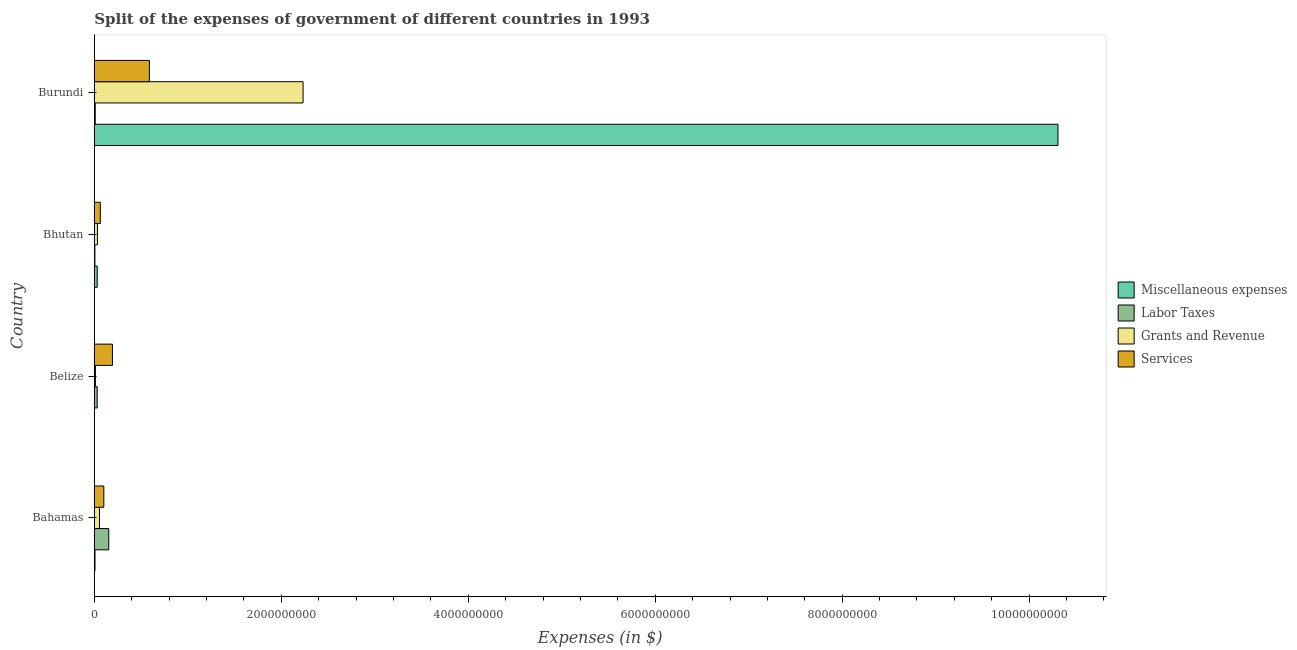Are the number of bars per tick equal to the number of legend labels?
Give a very brief answer. Yes. How many bars are there on the 4th tick from the top?
Provide a succinct answer. 4. How many bars are there on the 4th tick from the bottom?
Keep it short and to the point. 4. What is the label of the 4th group of bars from the top?
Provide a short and direct response. Bahamas. In how many cases, is the number of bars for a given country not equal to the number of legend labels?
Your answer should be compact. 0. What is the amount spent on grants and revenue in Belize?
Ensure brevity in your answer.  1.21e+07. Across all countries, what is the maximum amount spent on miscellaneous expenses?
Offer a very short reply. 1.03e+1. Across all countries, what is the minimum amount spent on services?
Give a very brief answer. 6.46e+07. In which country was the amount spent on services maximum?
Provide a short and direct response. Burundi. In which country was the amount spent on grants and revenue minimum?
Your response must be concise. Belize. What is the total amount spent on grants and revenue in the graph?
Your response must be concise. 2.33e+09. What is the difference between the amount spent on grants and revenue in Bhutan and that in Burundi?
Keep it short and to the point. -2.20e+09. What is the difference between the amount spent on services in Burundi and the amount spent on grants and revenue in Bahamas?
Make the answer very short. 5.34e+08. What is the average amount spent on services per country?
Keep it short and to the point. 2.38e+08. What is the difference between the amount spent on labor taxes and amount spent on grants and revenue in Bhutan?
Keep it short and to the point. -2.73e+07. What is the ratio of the amount spent on miscellaneous expenses in Bahamas to that in Belize?
Ensure brevity in your answer.  4.55. What is the difference between the highest and the second highest amount spent on grants and revenue?
Provide a short and direct response. 2.18e+09. What is the difference between the highest and the lowest amount spent on miscellaneous expenses?
Your answer should be compact. 1.03e+1. In how many countries, is the amount spent on labor taxes greater than the average amount spent on labor taxes taken over all countries?
Ensure brevity in your answer.  1. Is the sum of the amount spent on services in Bahamas and Bhutan greater than the maximum amount spent on grants and revenue across all countries?
Give a very brief answer. No. What does the 2nd bar from the top in Bahamas represents?
Provide a short and direct response. Grants and Revenue. What does the 1st bar from the bottom in Bahamas represents?
Give a very brief answer. Miscellaneous expenses. How many bars are there?
Keep it short and to the point. 16. Are all the bars in the graph horizontal?
Make the answer very short. Yes. What is the difference between two consecutive major ticks on the X-axis?
Offer a very short reply. 2.00e+09. Are the values on the major ticks of X-axis written in scientific E-notation?
Offer a very short reply. No. Does the graph contain any zero values?
Keep it short and to the point. No. What is the title of the graph?
Your answer should be very brief. Split of the expenses of government of different countries in 1993. Does "Budget management" appear as one of the legend labels in the graph?
Provide a short and direct response. No. What is the label or title of the X-axis?
Make the answer very short. Expenses (in $). What is the Expenses (in $) of Miscellaneous expenses in Bahamas?
Provide a short and direct response. 7.60e+06. What is the Expenses (in $) of Labor Taxes in Bahamas?
Ensure brevity in your answer.  1.55e+08. What is the Expenses (in $) in Grants and Revenue in Bahamas?
Give a very brief answer. 5.55e+07. What is the Expenses (in $) of Services in Bahamas?
Your answer should be compact. 1.02e+08. What is the Expenses (in $) in Miscellaneous expenses in Belize?
Ensure brevity in your answer.  1.67e+06. What is the Expenses (in $) of Labor Taxes in Belize?
Provide a short and direct response. 3.09e+07. What is the Expenses (in $) of Grants and Revenue in Belize?
Make the answer very short. 1.21e+07. What is the Expenses (in $) of Services in Belize?
Provide a short and direct response. 1.94e+08. What is the Expenses (in $) in Miscellaneous expenses in Bhutan?
Your answer should be very brief. 3.13e+07. What is the Expenses (in $) in Labor Taxes in Bhutan?
Your answer should be compact. 6.38e+06. What is the Expenses (in $) in Grants and Revenue in Bhutan?
Your answer should be very brief. 3.37e+07. What is the Expenses (in $) in Services in Bhutan?
Your answer should be compact. 6.46e+07. What is the Expenses (in $) in Miscellaneous expenses in Burundi?
Provide a short and direct response. 1.03e+1. What is the Expenses (in $) of Labor Taxes in Burundi?
Make the answer very short. 1.02e+07. What is the Expenses (in $) in Grants and Revenue in Burundi?
Give a very brief answer. 2.23e+09. What is the Expenses (in $) in Services in Burundi?
Offer a very short reply. 5.90e+08. Across all countries, what is the maximum Expenses (in $) in Miscellaneous expenses?
Make the answer very short. 1.03e+1. Across all countries, what is the maximum Expenses (in $) in Labor Taxes?
Your answer should be very brief. 1.55e+08. Across all countries, what is the maximum Expenses (in $) of Grants and Revenue?
Make the answer very short. 2.23e+09. Across all countries, what is the maximum Expenses (in $) of Services?
Offer a terse response. 5.90e+08. Across all countries, what is the minimum Expenses (in $) of Miscellaneous expenses?
Provide a succinct answer. 1.67e+06. Across all countries, what is the minimum Expenses (in $) of Labor Taxes?
Provide a succinct answer. 6.38e+06. Across all countries, what is the minimum Expenses (in $) in Grants and Revenue?
Keep it short and to the point. 1.21e+07. Across all countries, what is the minimum Expenses (in $) of Services?
Give a very brief answer. 6.46e+07. What is the total Expenses (in $) in Miscellaneous expenses in the graph?
Offer a very short reply. 1.03e+1. What is the total Expenses (in $) of Labor Taxes in the graph?
Your answer should be very brief. 2.02e+08. What is the total Expenses (in $) of Grants and Revenue in the graph?
Ensure brevity in your answer.  2.33e+09. What is the total Expenses (in $) of Services in the graph?
Make the answer very short. 9.50e+08. What is the difference between the Expenses (in $) in Miscellaneous expenses in Bahamas and that in Belize?
Your response must be concise. 5.93e+06. What is the difference between the Expenses (in $) in Labor Taxes in Bahamas and that in Belize?
Keep it short and to the point. 1.24e+08. What is the difference between the Expenses (in $) of Grants and Revenue in Bahamas and that in Belize?
Make the answer very short. 4.34e+07. What is the difference between the Expenses (in $) in Services in Bahamas and that in Belize?
Offer a very short reply. -9.22e+07. What is the difference between the Expenses (in $) in Miscellaneous expenses in Bahamas and that in Bhutan?
Provide a succinct answer. -2.37e+07. What is the difference between the Expenses (in $) in Labor Taxes in Bahamas and that in Bhutan?
Offer a very short reply. 1.48e+08. What is the difference between the Expenses (in $) in Grants and Revenue in Bahamas and that in Bhutan?
Provide a succinct answer. 2.18e+07. What is the difference between the Expenses (in $) in Services in Bahamas and that in Bhutan?
Ensure brevity in your answer.  3.73e+07. What is the difference between the Expenses (in $) in Miscellaneous expenses in Bahamas and that in Burundi?
Give a very brief answer. -1.03e+1. What is the difference between the Expenses (in $) in Labor Taxes in Bahamas and that in Burundi?
Provide a succinct answer. 1.45e+08. What is the difference between the Expenses (in $) in Grants and Revenue in Bahamas and that in Burundi?
Make the answer very short. -2.18e+09. What is the difference between the Expenses (in $) of Services in Bahamas and that in Burundi?
Make the answer very short. -4.88e+08. What is the difference between the Expenses (in $) in Miscellaneous expenses in Belize and that in Bhutan?
Offer a very short reply. -2.96e+07. What is the difference between the Expenses (in $) in Labor Taxes in Belize and that in Bhutan?
Offer a terse response. 2.45e+07. What is the difference between the Expenses (in $) in Grants and Revenue in Belize and that in Bhutan?
Offer a very short reply. -2.16e+07. What is the difference between the Expenses (in $) of Services in Belize and that in Bhutan?
Give a very brief answer. 1.30e+08. What is the difference between the Expenses (in $) of Miscellaneous expenses in Belize and that in Burundi?
Offer a terse response. -1.03e+1. What is the difference between the Expenses (in $) of Labor Taxes in Belize and that in Burundi?
Keep it short and to the point. 2.07e+07. What is the difference between the Expenses (in $) of Grants and Revenue in Belize and that in Burundi?
Ensure brevity in your answer.  -2.22e+09. What is the difference between the Expenses (in $) of Services in Belize and that in Burundi?
Provide a succinct answer. -3.96e+08. What is the difference between the Expenses (in $) in Miscellaneous expenses in Bhutan and that in Burundi?
Your answer should be compact. -1.03e+1. What is the difference between the Expenses (in $) of Labor Taxes in Bhutan and that in Burundi?
Provide a short and direct response. -3.82e+06. What is the difference between the Expenses (in $) in Grants and Revenue in Bhutan and that in Burundi?
Keep it short and to the point. -2.20e+09. What is the difference between the Expenses (in $) of Services in Bhutan and that in Burundi?
Provide a succinct answer. -5.25e+08. What is the difference between the Expenses (in $) of Miscellaneous expenses in Bahamas and the Expenses (in $) of Labor Taxes in Belize?
Your answer should be compact. -2.33e+07. What is the difference between the Expenses (in $) in Miscellaneous expenses in Bahamas and the Expenses (in $) in Grants and Revenue in Belize?
Make the answer very short. -4.50e+06. What is the difference between the Expenses (in $) in Miscellaneous expenses in Bahamas and the Expenses (in $) in Services in Belize?
Your response must be concise. -1.86e+08. What is the difference between the Expenses (in $) in Labor Taxes in Bahamas and the Expenses (in $) in Grants and Revenue in Belize?
Ensure brevity in your answer.  1.43e+08. What is the difference between the Expenses (in $) in Labor Taxes in Bahamas and the Expenses (in $) in Services in Belize?
Ensure brevity in your answer.  -3.93e+07. What is the difference between the Expenses (in $) of Grants and Revenue in Bahamas and the Expenses (in $) of Services in Belize?
Your response must be concise. -1.39e+08. What is the difference between the Expenses (in $) in Miscellaneous expenses in Bahamas and the Expenses (in $) in Labor Taxes in Bhutan?
Make the answer very short. 1.22e+06. What is the difference between the Expenses (in $) of Miscellaneous expenses in Bahamas and the Expenses (in $) of Grants and Revenue in Bhutan?
Your response must be concise. -2.61e+07. What is the difference between the Expenses (in $) in Miscellaneous expenses in Bahamas and the Expenses (in $) in Services in Bhutan?
Give a very brief answer. -5.70e+07. What is the difference between the Expenses (in $) in Labor Taxes in Bahamas and the Expenses (in $) in Grants and Revenue in Bhutan?
Offer a terse response. 1.21e+08. What is the difference between the Expenses (in $) of Labor Taxes in Bahamas and the Expenses (in $) of Services in Bhutan?
Ensure brevity in your answer.  9.02e+07. What is the difference between the Expenses (in $) of Grants and Revenue in Bahamas and the Expenses (in $) of Services in Bhutan?
Your response must be concise. -9.07e+06. What is the difference between the Expenses (in $) of Miscellaneous expenses in Bahamas and the Expenses (in $) of Labor Taxes in Burundi?
Give a very brief answer. -2.60e+06. What is the difference between the Expenses (in $) of Miscellaneous expenses in Bahamas and the Expenses (in $) of Grants and Revenue in Burundi?
Keep it short and to the point. -2.23e+09. What is the difference between the Expenses (in $) in Miscellaneous expenses in Bahamas and the Expenses (in $) in Services in Burundi?
Make the answer very short. -5.82e+08. What is the difference between the Expenses (in $) in Labor Taxes in Bahamas and the Expenses (in $) in Grants and Revenue in Burundi?
Give a very brief answer. -2.08e+09. What is the difference between the Expenses (in $) in Labor Taxes in Bahamas and the Expenses (in $) in Services in Burundi?
Provide a succinct answer. -4.35e+08. What is the difference between the Expenses (in $) in Grants and Revenue in Bahamas and the Expenses (in $) in Services in Burundi?
Ensure brevity in your answer.  -5.34e+08. What is the difference between the Expenses (in $) of Miscellaneous expenses in Belize and the Expenses (in $) of Labor Taxes in Bhutan?
Give a very brief answer. -4.71e+06. What is the difference between the Expenses (in $) in Miscellaneous expenses in Belize and the Expenses (in $) in Grants and Revenue in Bhutan?
Make the answer very short. -3.20e+07. What is the difference between the Expenses (in $) of Miscellaneous expenses in Belize and the Expenses (in $) of Services in Bhutan?
Offer a very short reply. -6.29e+07. What is the difference between the Expenses (in $) of Labor Taxes in Belize and the Expenses (in $) of Grants and Revenue in Bhutan?
Make the answer very short. -2.81e+06. What is the difference between the Expenses (in $) of Labor Taxes in Belize and the Expenses (in $) of Services in Bhutan?
Your answer should be compact. -3.37e+07. What is the difference between the Expenses (in $) in Grants and Revenue in Belize and the Expenses (in $) in Services in Bhutan?
Ensure brevity in your answer.  -5.25e+07. What is the difference between the Expenses (in $) in Miscellaneous expenses in Belize and the Expenses (in $) in Labor Taxes in Burundi?
Offer a very short reply. -8.53e+06. What is the difference between the Expenses (in $) in Miscellaneous expenses in Belize and the Expenses (in $) in Grants and Revenue in Burundi?
Offer a terse response. -2.23e+09. What is the difference between the Expenses (in $) in Miscellaneous expenses in Belize and the Expenses (in $) in Services in Burundi?
Ensure brevity in your answer.  -5.88e+08. What is the difference between the Expenses (in $) of Labor Taxes in Belize and the Expenses (in $) of Grants and Revenue in Burundi?
Your answer should be very brief. -2.20e+09. What is the difference between the Expenses (in $) of Labor Taxes in Belize and the Expenses (in $) of Services in Burundi?
Your answer should be compact. -5.59e+08. What is the difference between the Expenses (in $) in Grants and Revenue in Belize and the Expenses (in $) in Services in Burundi?
Offer a terse response. -5.78e+08. What is the difference between the Expenses (in $) in Miscellaneous expenses in Bhutan and the Expenses (in $) in Labor Taxes in Burundi?
Your answer should be compact. 2.11e+07. What is the difference between the Expenses (in $) in Miscellaneous expenses in Bhutan and the Expenses (in $) in Grants and Revenue in Burundi?
Your response must be concise. -2.20e+09. What is the difference between the Expenses (in $) in Miscellaneous expenses in Bhutan and the Expenses (in $) in Services in Burundi?
Give a very brief answer. -5.58e+08. What is the difference between the Expenses (in $) of Labor Taxes in Bhutan and the Expenses (in $) of Grants and Revenue in Burundi?
Provide a short and direct response. -2.23e+09. What is the difference between the Expenses (in $) of Labor Taxes in Bhutan and the Expenses (in $) of Services in Burundi?
Your answer should be very brief. -5.83e+08. What is the difference between the Expenses (in $) of Grants and Revenue in Bhutan and the Expenses (in $) of Services in Burundi?
Provide a succinct answer. -5.56e+08. What is the average Expenses (in $) in Miscellaneous expenses per country?
Your answer should be compact. 2.59e+09. What is the average Expenses (in $) in Labor Taxes per country?
Keep it short and to the point. 5.06e+07. What is the average Expenses (in $) of Grants and Revenue per country?
Provide a short and direct response. 5.84e+08. What is the average Expenses (in $) of Services per country?
Your answer should be very brief. 2.38e+08. What is the difference between the Expenses (in $) in Miscellaneous expenses and Expenses (in $) in Labor Taxes in Bahamas?
Give a very brief answer. -1.47e+08. What is the difference between the Expenses (in $) in Miscellaneous expenses and Expenses (in $) in Grants and Revenue in Bahamas?
Ensure brevity in your answer.  -4.79e+07. What is the difference between the Expenses (in $) in Miscellaneous expenses and Expenses (in $) in Services in Bahamas?
Your answer should be very brief. -9.43e+07. What is the difference between the Expenses (in $) in Labor Taxes and Expenses (in $) in Grants and Revenue in Bahamas?
Give a very brief answer. 9.93e+07. What is the difference between the Expenses (in $) in Labor Taxes and Expenses (in $) in Services in Bahamas?
Your response must be concise. 5.29e+07. What is the difference between the Expenses (in $) in Grants and Revenue and Expenses (in $) in Services in Bahamas?
Keep it short and to the point. -4.64e+07. What is the difference between the Expenses (in $) in Miscellaneous expenses and Expenses (in $) in Labor Taxes in Belize?
Provide a short and direct response. -2.92e+07. What is the difference between the Expenses (in $) of Miscellaneous expenses and Expenses (in $) of Grants and Revenue in Belize?
Your answer should be compact. -1.04e+07. What is the difference between the Expenses (in $) of Miscellaneous expenses and Expenses (in $) of Services in Belize?
Offer a very short reply. -1.92e+08. What is the difference between the Expenses (in $) in Labor Taxes and Expenses (in $) in Grants and Revenue in Belize?
Your answer should be compact. 1.88e+07. What is the difference between the Expenses (in $) of Labor Taxes and Expenses (in $) of Services in Belize?
Give a very brief answer. -1.63e+08. What is the difference between the Expenses (in $) of Grants and Revenue and Expenses (in $) of Services in Belize?
Your response must be concise. -1.82e+08. What is the difference between the Expenses (in $) of Miscellaneous expenses and Expenses (in $) of Labor Taxes in Bhutan?
Make the answer very short. 2.49e+07. What is the difference between the Expenses (in $) of Miscellaneous expenses and Expenses (in $) of Grants and Revenue in Bhutan?
Offer a very short reply. -2.41e+06. What is the difference between the Expenses (in $) of Miscellaneous expenses and Expenses (in $) of Services in Bhutan?
Your answer should be very brief. -3.33e+07. What is the difference between the Expenses (in $) in Labor Taxes and Expenses (in $) in Grants and Revenue in Bhutan?
Offer a very short reply. -2.73e+07. What is the difference between the Expenses (in $) in Labor Taxes and Expenses (in $) in Services in Bhutan?
Make the answer very short. -5.82e+07. What is the difference between the Expenses (in $) of Grants and Revenue and Expenses (in $) of Services in Bhutan?
Ensure brevity in your answer.  -3.09e+07. What is the difference between the Expenses (in $) of Miscellaneous expenses and Expenses (in $) of Labor Taxes in Burundi?
Provide a short and direct response. 1.03e+1. What is the difference between the Expenses (in $) in Miscellaneous expenses and Expenses (in $) in Grants and Revenue in Burundi?
Offer a very short reply. 8.07e+09. What is the difference between the Expenses (in $) in Miscellaneous expenses and Expenses (in $) in Services in Burundi?
Provide a short and direct response. 9.72e+09. What is the difference between the Expenses (in $) of Labor Taxes and Expenses (in $) of Grants and Revenue in Burundi?
Ensure brevity in your answer.  -2.22e+09. What is the difference between the Expenses (in $) of Labor Taxes and Expenses (in $) of Services in Burundi?
Offer a very short reply. -5.80e+08. What is the difference between the Expenses (in $) of Grants and Revenue and Expenses (in $) of Services in Burundi?
Your answer should be compact. 1.64e+09. What is the ratio of the Expenses (in $) in Miscellaneous expenses in Bahamas to that in Belize?
Your response must be concise. 4.55. What is the ratio of the Expenses (in $) of Labor Taxes in Bahamas to that in Belize?
Your response must be concise. 5.01. What is the ratio of the Expenses (in $) in Grants and Revenue in Bahamas to that in Belize?
Provide a succinct answer. 4.59. What is the ratio of the Expenses (in $) of Services in Bahamas to that in Belize?
Give a very brief answer. 0.53. What is the ratio of the Expenses (in $) of Miscellaneous expenses in Bahamas to that in Bhutan?
Provide a short and direct response. 0.24. What is the ratio of the Expenses (in $) of Labor Taxes in Bahamas to that in Bhutan?
Offer a very short reply. 24.27. What is the ratio of the Expenses (in $) of Grants and Revenue in Bahamas to that in Bhutan?
Offer a terse response. 1.65. What is the ratio of the Expenses (in $) in Services in Bahamas to that in Bhutan?
Provide a short and direct response. 1.58. What is the ratio of the Expenses (in $) in Miscellaneous expenses in Bahamas to that in Burundi?
Ensure brevity in your answer.  0. What is the ratio of the Expenses (in $) in Labor Taxes in Bahamas to that in Burundi?
Keep it short and to the point. 15.18. What is the ratio of the Expenses (in $) in Grants and Revenue in Bahamas to that in Burundi?
Make the answer very short. 0.02. What is the ratio of the Expenses (in $) of Services in Bahamas to that in Burundi?
Keep it short and to the point. 0.17. What is the ratio of the Expenses (in $) in Miscellaneous expenses in Belize to that in Bhutan?
Offer a terse response. 0.05. What is the ratio of the Expenses (in $) of Labor Taxes in Belize to that in Bhutan?
Give a very brief answer. 4.85. What is the ratio of the Expenses (in $) of Grants and Revenue in Belize to that in Bhutan?
Provide a short and direct response. 0.36. What is the ratio of the Expenses (in $) in Services in Belize to that in Bhutan?
Ensure brevity in your answer.  3.01. What is the ratio of the Expenses (in $) of Miscellaneous expenses in Belize to that in Burundi?
Your answer should be very brief. 0. What is the ratio of the Expenses (in $) in Labor Taxes in Belize to that in Burundi?
Offer a very short reply. 3.03. What is the ratio of the Expenses (in $) in Grants and Revenue in Belize to that in Burundi?
Your response must be concise. 0.01. What is the ratio of the Expenses (in $) of Services in Belize to that in Burundi?
Ensure brevity in your answer.  0.33. What is the ratio of the Expenses (in $) of Miscellaneous expenses in Bhutan to that in Burundi?
Your answer should be compact. 0. What is the ratio of the Expenses (in $) of Labor Taxes in Bhutan to that in Burundi?
Give a very brief answer. 0.63. What is the ratio of the Expenses (in $) of Grants and Revenue in Bhutan to that in Burundi?
Ensure brevity in your answer.  0.02. What is the ratio of the Expenses (in $) in Services in Bhutan to that in Burundi?
Provide a succinct answer. 0.11. What is the difference between the highest and the second highest Expenses (in $) in Miscellaneous expenses?
Ensure brevity in your answer.  1.03e+1. What is the difference between the highest and the second highest Expenses (in $) in Labor Taxes?
Your response must be concise. 1.24e+08. What is the difference between the highest and the second highest Expenses (in $) of Grants and Revenue?
Offer a very short reply. 2.18e+09. What is the difference between the highest and the second highest Expenses (in $) in Services?
Ensure brevity in your answer.  3.96e+08. What is the difference between the highest and the lowest Expenses (in $) in Miscellaneous expenses?
Provide a succinct answer. 1.03e+1. What is the difference between the highest and the lowest Expenses (in $) of Labor Taxes?
Make the answer very short. 1.48e+08. What is the difference between the highest and the lowest Expenses (in $) of Grants and Revenue?
Offer a terse response. 2.22e+09. What is the difference between the highest and the lowest Expenses (in $) of Services?
Provide a succinct answer. 5.25e+08. 